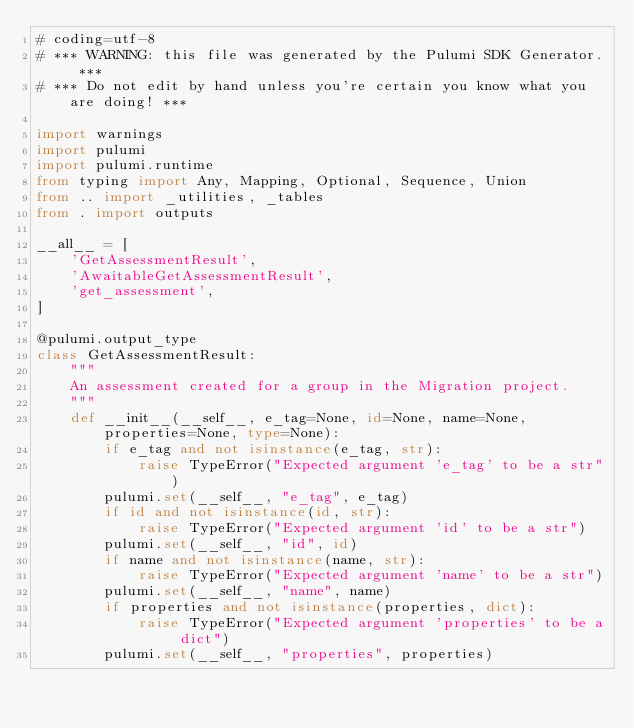<code> <loc_0><loc_0><loc_500><loc_500><_Python_># coding=utf-8
# *** WARNING: this file was generated by the Pulumi SDK Generator. ***
# *** Do not edit by hand unless you're certain you know what you are doing! ***

import warnings
import pulumi
import pulumi.runtime
from typing import Any, Mapping, Optional, Sequence, Union
from .. import _utilities, _tables
from . import outputs

__all__ = [
    'GetAssessmentResult',
    'AwaitableGetAssessmentResult',
    'get_assessment',
]

@pulumi.output_type
class GetAssessmentResult:
    """
    An assessment created for a group in the Migration project.
    """
    def __init__(__self__, e_tag=None, id=None, name=None, properties=None, type=None):
        if e_tag and not isinstance(e_tag, str):
            raise TypeError("Expected argument 'e_tag' to be a str")
        pulumi.set(__self__, "e_tag", e_tag)
        if id and not isinstance(id, str):
            raise TypeError("Expected argument 'id' to be a str")
        pulumi.set(__self__, "id", id)
        if name and not isinstance(name, str):
            raise TypeError("Expected argument 'name' to be a str")
        pulumi.set(__self__, "name", name)
        if properties and not isinstance(properties, dict):
            raise TypeError("Expected argument 'properties' to be a dict")
        pulumi.set(__self__, "properties", properties)</code> 